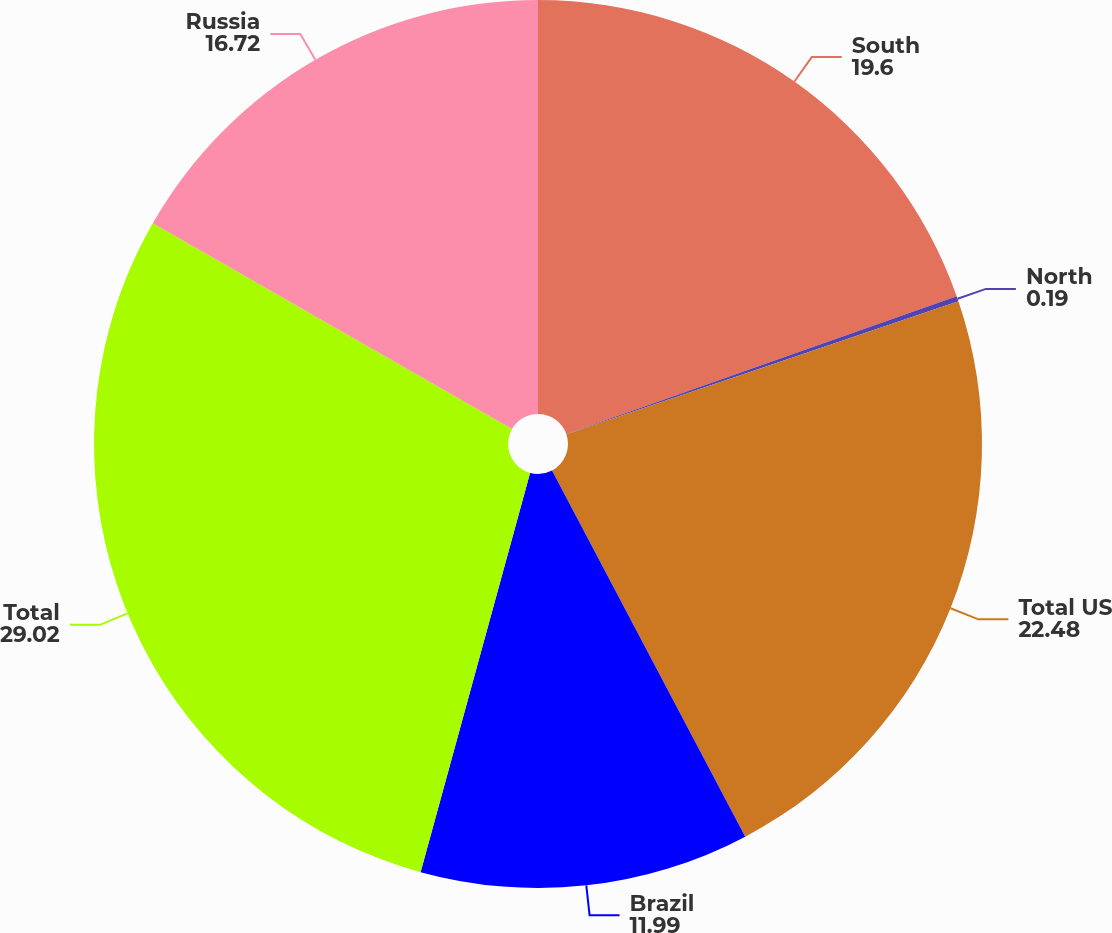Convert chart. <chart><loc_0><loc_0><loc_500><loc_500><pie_chart><fcel>South<fcel>North<fcel>Total US<fcel>Brazil<fcel>Total<fcel>Russia<nl><fcel>19.6%<fcel>0.19%<fcel>22.48%<fcel>11.99%<fcel>29.02%<fcel>16.72%<nl></chart> 